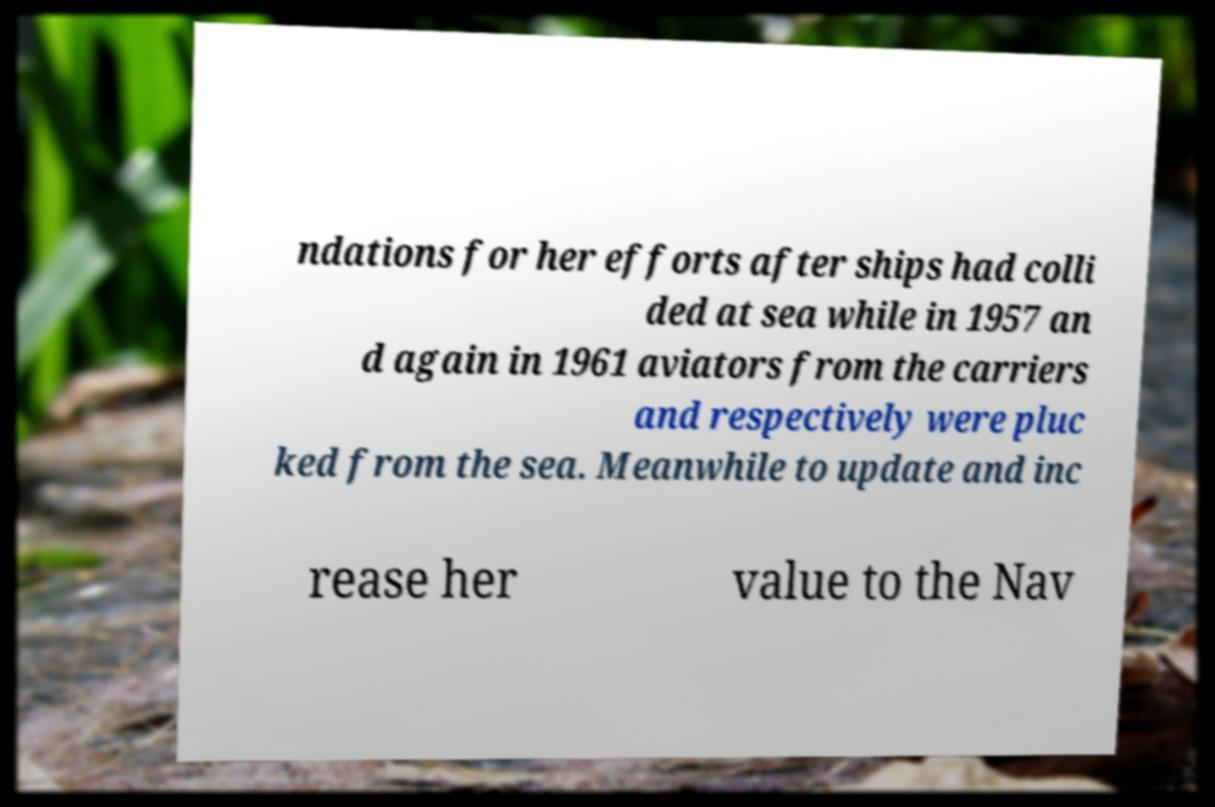Please identify and transcribe the text found in this image. ndations for her efforts after ships had colli ded at sea while in 1957 an d again in 1961 aviators from the carriers and respectively were pluc ked from the sea. Meanwhile to update and inc rease her value to the Nav 